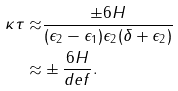Convert formula to latex. <formula><loc_0><loc_0><loc_500><loc_500>\kappa \tau \approx & \frac { \pm 6 H } { ( \epsilon _ { 2 } - \epsilon _ { 1 } ) \epsilon _ { 2 } ( \delta + \epsilon _ { 2 } ) } \\ \approx & \pm \frac { 6 H } { d e f } .</formula> 